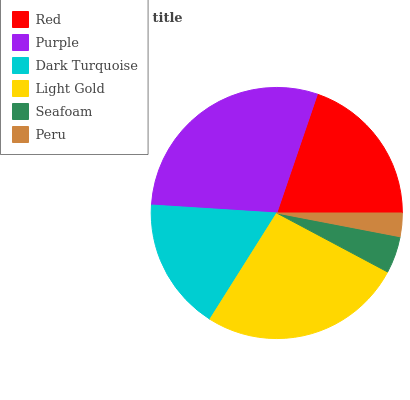Is Peru the minimum?
Answer yes or no. Yes. Is Purple the maximum?
Answer yes or no. Yes. Is Dark Turquoise the minimum?
Answer yes or no. No. Is Dark Turquoise the maximum?
Answer yes or no. No. Is Purple greater than Dark Turquoise?
Answer yes or no. Yes. Is Dark Turquoise less than Purple?
Answer yes or no. Yes. Is Dark Turquoise greater than Purple?
Answer yes or no. No. Is Purple less than Dark Turquoise?
Answer yes or no. No. Is Red the high median?
Answer yes or no. Yes. Is Dark Turquoise the low median?
Answer yes or no. Yes. Is Seafoam the high median?
Answer yes or no. No. Is Purple the low median?
Answer yes or no. No. 